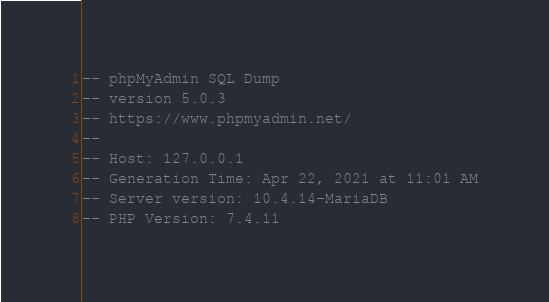Convert code to text. <code><loc_0><loc_0><loc_500><loc_500><_SQL_>-- phpMyAdmin SQL Dump
-- version 5.0.3
-- https://www.phpmyadmin.net/
--
-- Host: 127.0.0.1
-- Generation Time: Apr 22, 2021 at 11:01 AM
-- Server version: 10.4.14-MariaDB
-- PHP Version: 7.4.11
</code> 